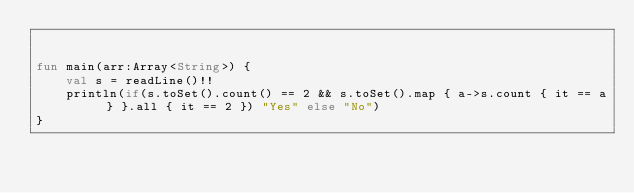<code> <loc_0><loc_0><loc_500><loc_500><_Kotlin_>

fun main(arr:Array<String>) {
    val s = readLine()!!
    println(if(s.toSet().count() == 2 && s.toSet().map { a->s.count { it == a } }.all { it == 2 }) "Yes" else "No")
}

</code> 